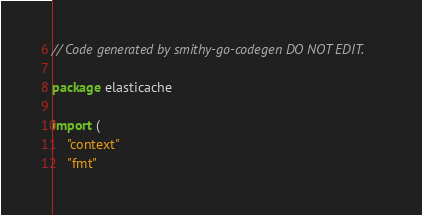Convert code to text. <code><loc_0><loc_0><loc_500><loc_500><_Go_>// Code generated by smithy-go-codegen DO NOT EDIT.

package elasticache

import (
	"context"
	"fmt"</code> 